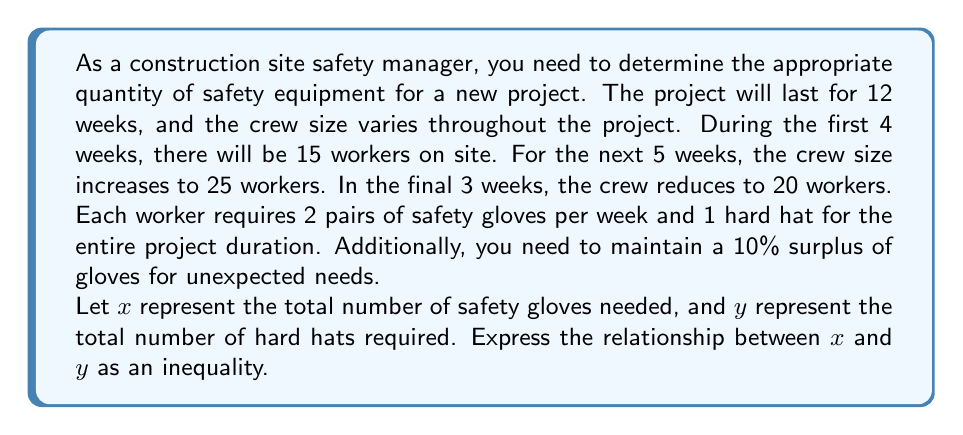Show me your answer to this math problem. Let's break this problem down step by step:

1. Calculate the total number of worker-weeks:
   - First 4 weeks: $4 \times 15 = 60$ worker-weeks
   - Next 5 weeks: $5 \times 25 = 125$ worker-weeks
   - Final 3 weeks: $3 \times 20 = 60$ worker-weeks
   - Total: $60 + 125 + 60 = 245$ worker-weeks

2. Calculate the number of gloves needed:
   - Each worker needs 2 pairs per week
   - Total gloves without surplus: $245 \times 2 = 490$ pairs
   - Add 10% surplus: $490 \times 1.1 = 539$ pairs
   Therefore, $x = 539$

3. Calculate the number of hard hats needed:
   - Maximum number of workers at any point: 25
   - Add 10% surplus: $25 \times 1.1 = 27.5$, round up to 28
   Therefore, $y = 28$

4. Express the relationship as an inequality:
   Since we need more gloves than hard hats, we can write:
   $$x > 19y$$

   This is because $\frac{539}{28} \approx 19.25$, so $x$ is always greater than 19 times $y$.
Answer: $x > 19y$, where $x$ represents the total number of safety gloves and $y$ represents the total number of hard hats. 